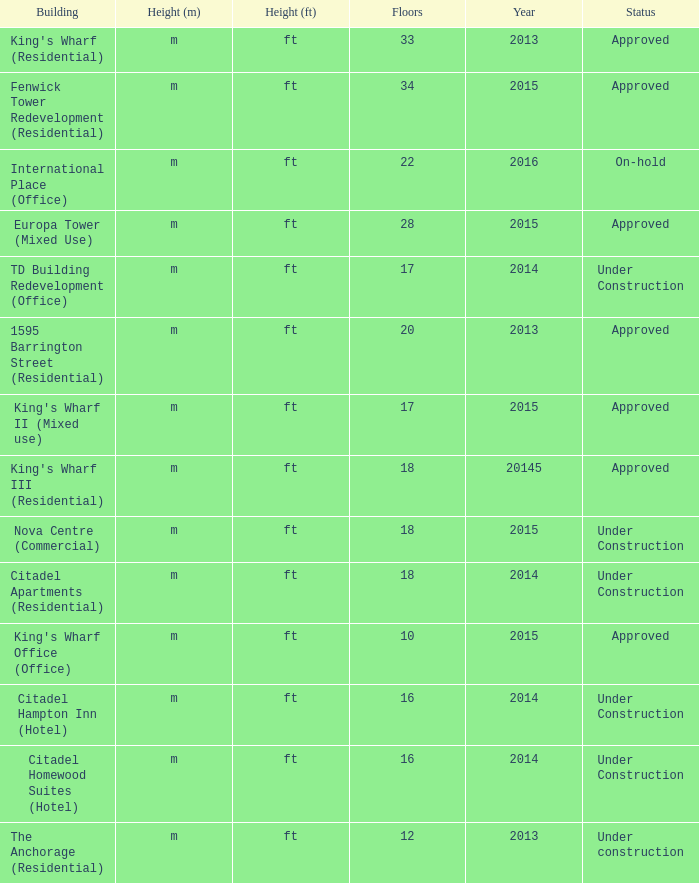What are the number of floors for the building of td building redevelopment (office)? 17.0. 